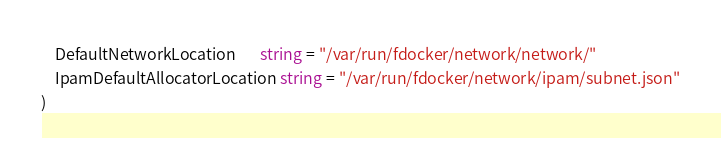<code> <loc_0><loc_0><loc_500><loc_500><_Go_>	DefaultNetworkLocation       string = "/var/run/fdocker/network/network/"
	IpamDefaultAllocatorLocation string = "/var/run/fdocker/network/ipam/subnet.json"
)
</code> 